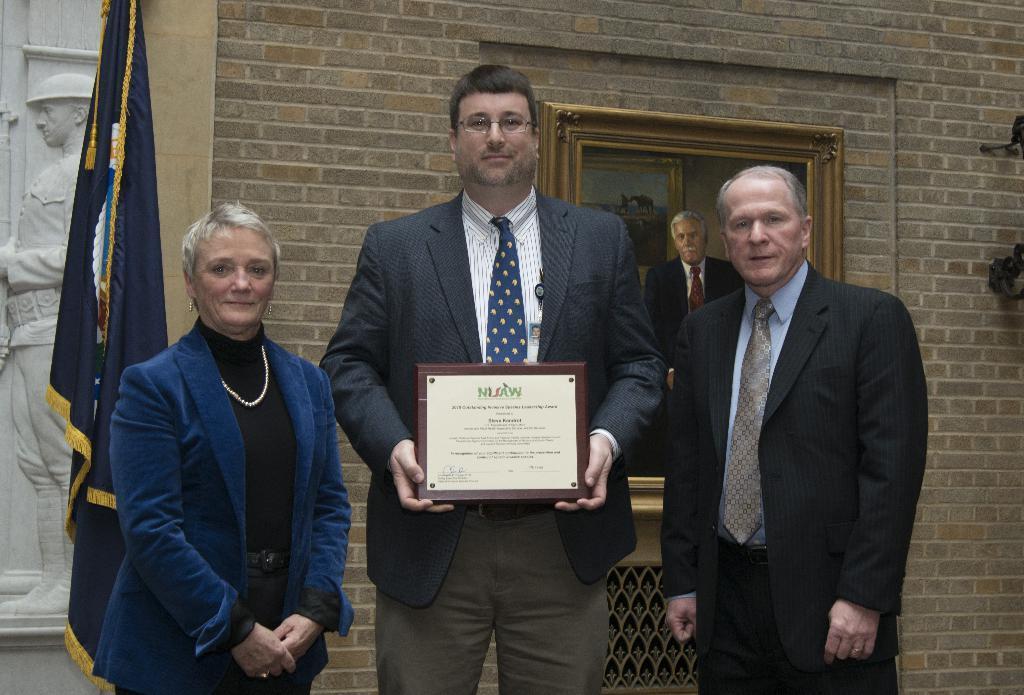In one or two sentences, can you explain what this image depicts? In this image we can see many persons standing. In the background we can see photo frame, flag, sculpture and wall. 